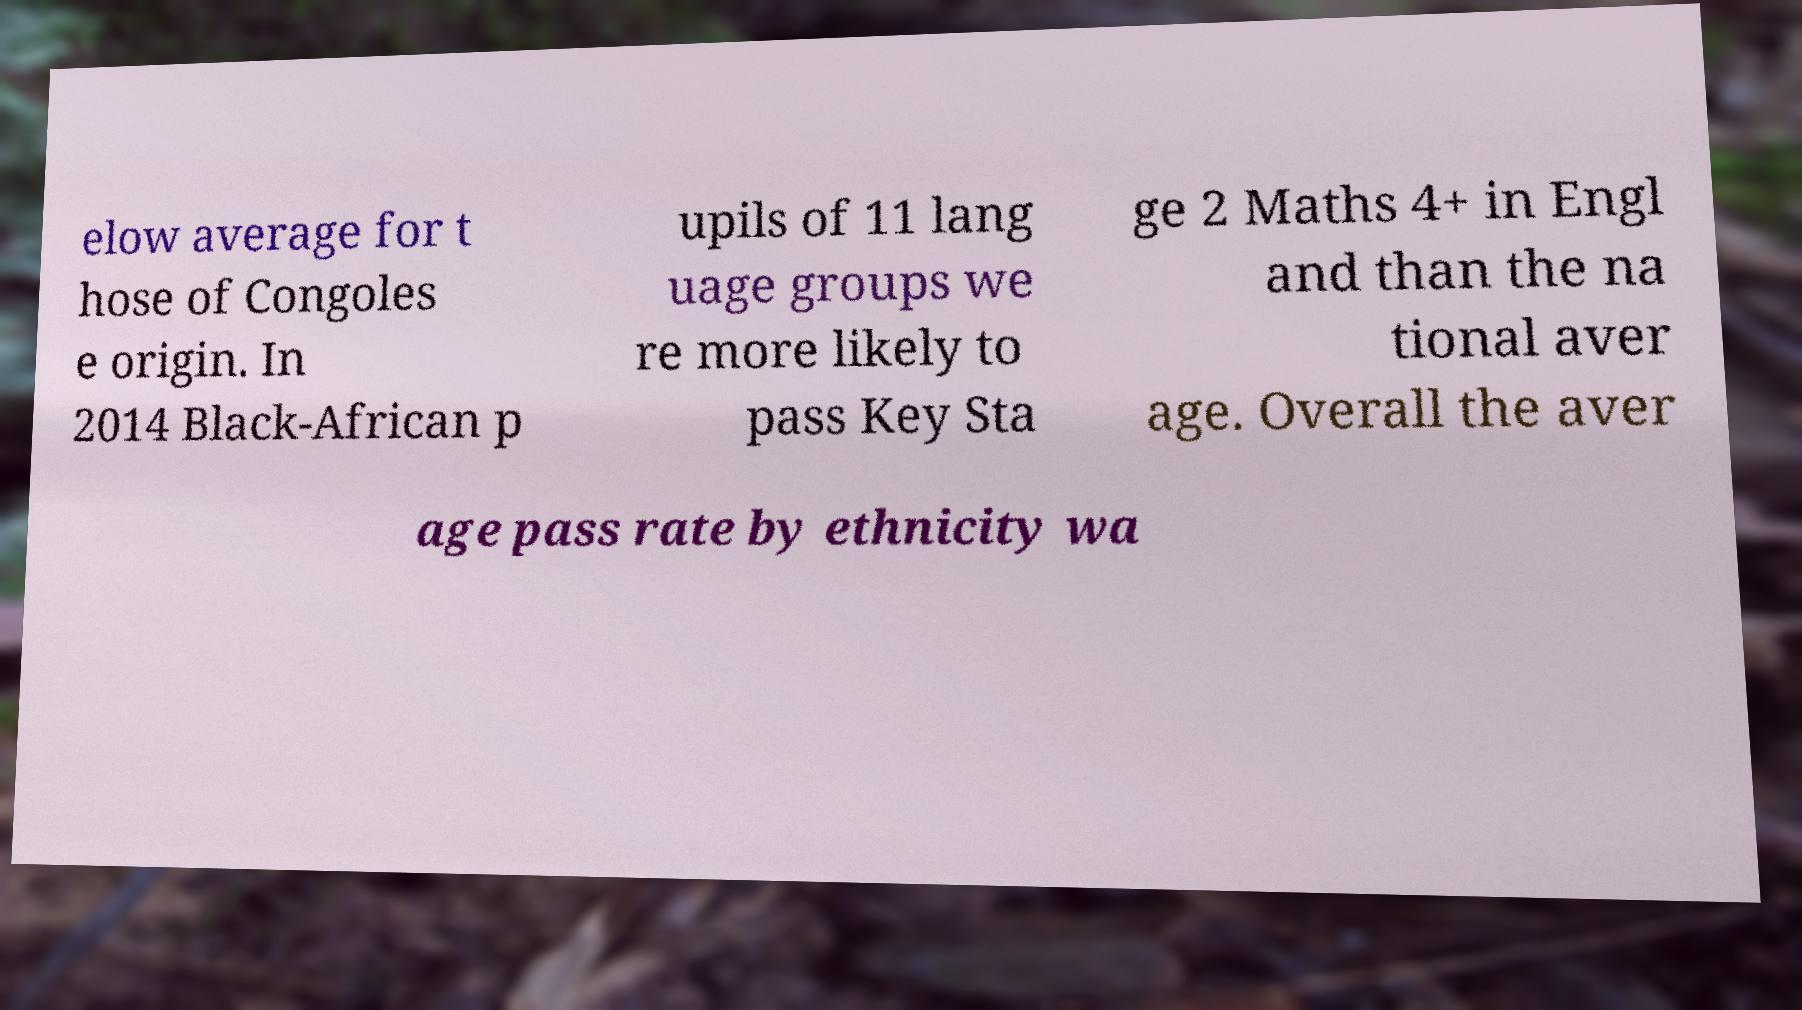What messages or text are displayed in this image? I need them in a readable, typed format. elow average for t hose of Congoles e origin. In 2014 Black-African p upils of 11 lang uage groups we re more likely to pass Key Sta ge 2 Maths 4+ in Engl and than the na tional aver age. Overall the aver age pass rate by ethnicity wa 